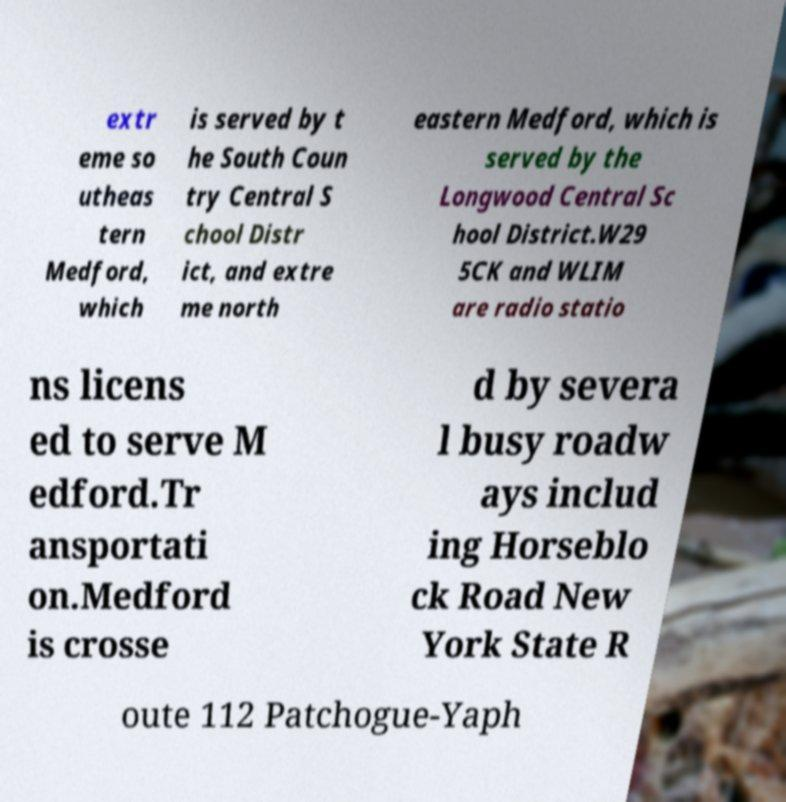For documentation purposes, I need the text within this image transcribed. Could you provide that? extr eme so utheas tern Medford, which is served by t he South Coun try Central S chool Distr ict, and extre me north eastern Medford, which is served by the Longwood Central Sc hool District.W29 5CK and WLIM are radio statio ns licens ed to serve M edford.Tr ansportati on.Medford is crosse d by severa l busy roadw ays includ ing Horseblo ck Road New York State R oute 112 Patchogue-Yaph 